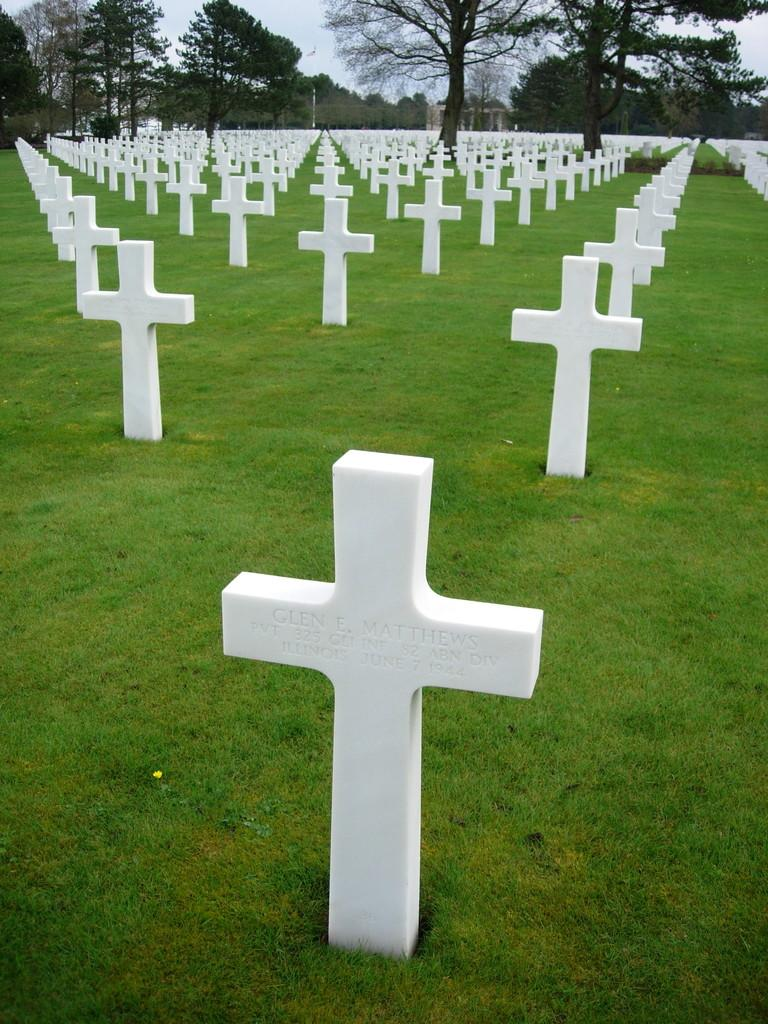What symbols can be seen on the grass in the image? There are cross symbols on the grass in the image. What type of vegetation is visible in the background of the image? There are trees visible in the background of the image. What structure can be seen in the background of the image? There is a pole in the background of the image. What is visible in the sky in the image? The sky is visible in the background of the image. What type of doctor is standing near the pole in the image? There is no doctor present in the image; it only features cross symbols on the grass, trees in the background, a pole, and the sky. How many passengers are visible in the image? There are no passengers present in the image. 